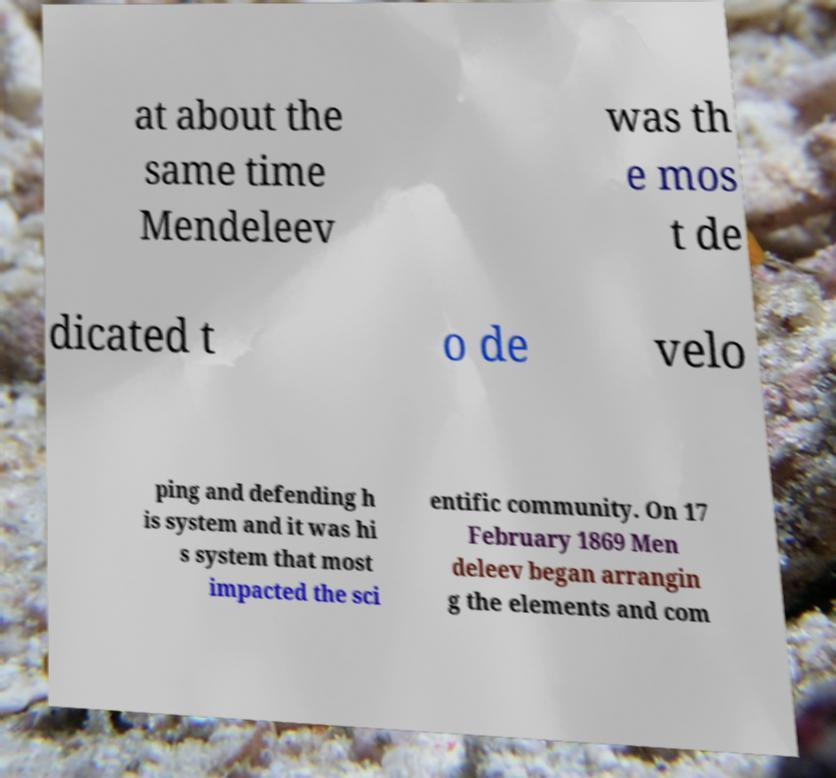What messages or text are displayed in this image? I need them in a readable, typed format. at about the same time Mendeleev was th e mos t de dicated t o de velo ping and defending h is system and it was hi s system that most impacted the sci entific community. On 17 February 1869 Men deleev began arrangin g the elements and com 